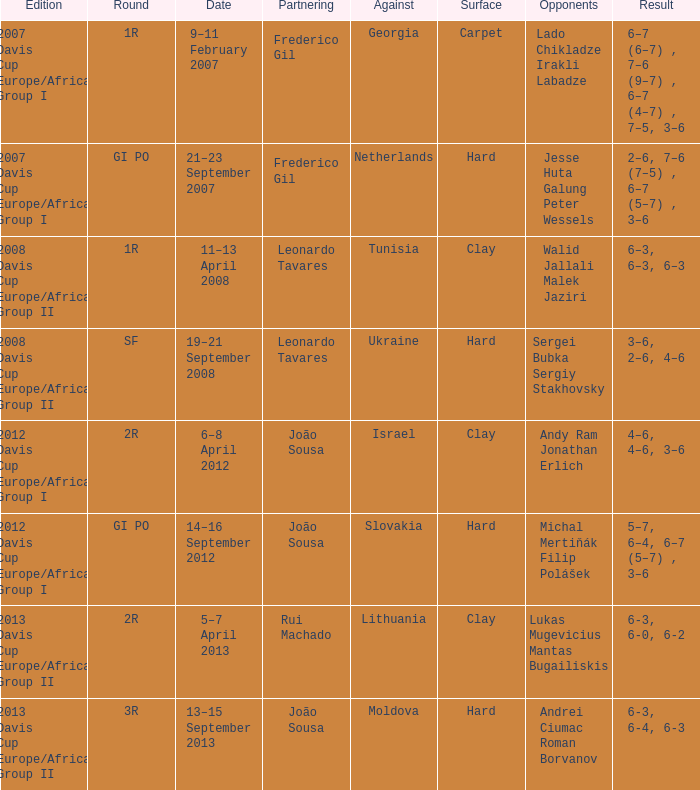In what edition was the outcome 6-3, 6-0, 6-2? 2013 Davis Cup Europe/Africa Group II. 